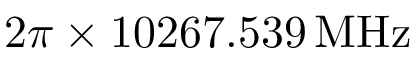<formula> <loc_0><loc_0><loc_500><loc_500>2 \pi \times 1 0 2 6 7 . 5 3 9 \, M H z</formula> 